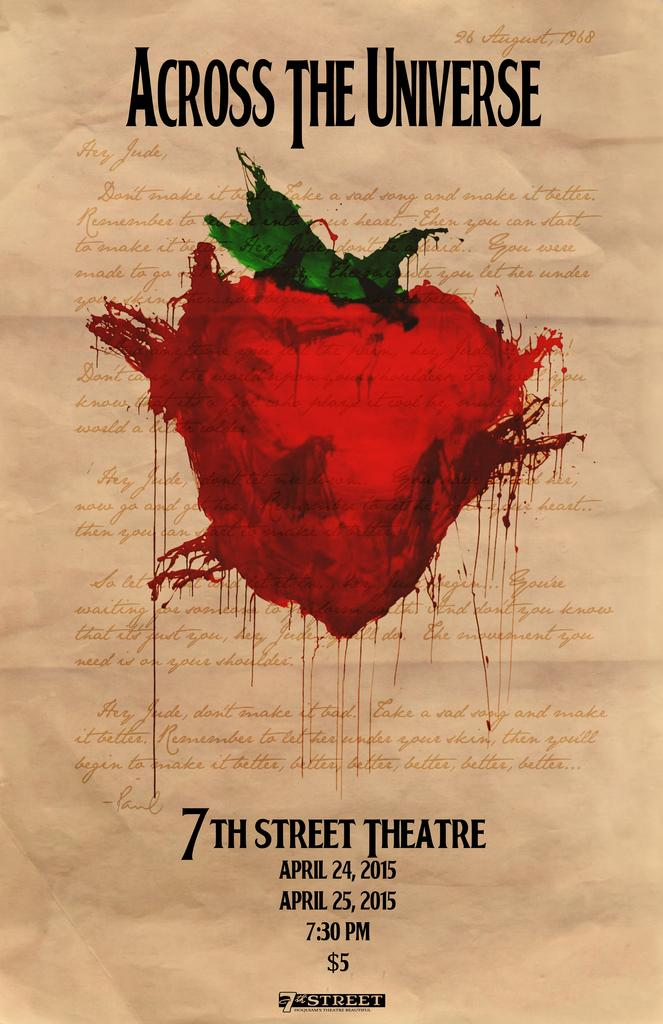<image>
Present a compact description of the photo's key features. An ad for Across the Universe from 2015 says that tickets are five dollars. 